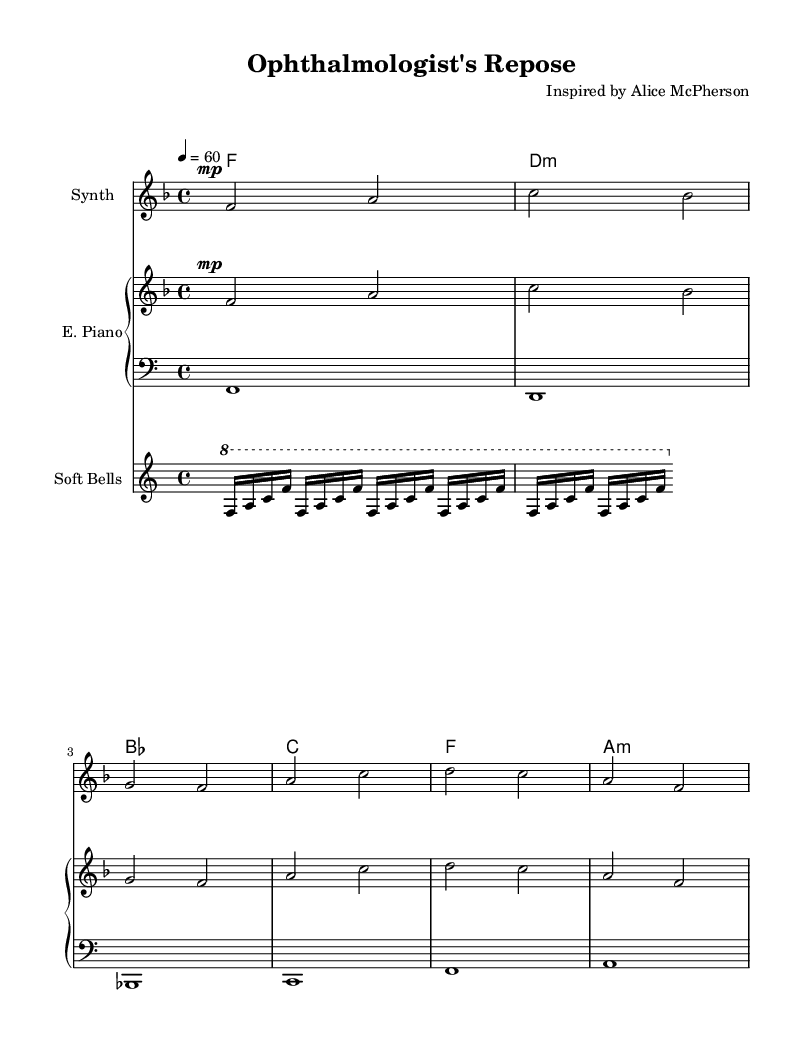What is the key signature of this music? The key signature is determined by the number of sharps or flats present at the beginning of the staff. In this case, there are no sharps or flats visible, indicating that it is F major, which has one flat.
Answer: F major What is the time signature of this piece? The time signature is indicated at the beginning of the music with two numbers, one above the other. Here, the time signature is 4 over 4, which means there are four beats in each measure.
Answer: 4/4 What is the tempo marking of the piece? The tempo is shown at the beginning as text with a number indicating beats per minute. In this score, it is noted as 4 equals 60, signifying a slow pace.
Answer: 60 How many measures are in the melody? To find the number of measures, count how many times the vertical bar lines appear, which indicate the end of each measure. There are six measures in total in the melody.
Answer: 6 What is the first note of the melody? The first note can be found at the beginning of the melody line, which is notated on the staff. The first note here is F, as indicated in the relative pitch notation.
Answer: F What type of instrument is used for the harmony? The instrument designation appears in the music score as "E. Piano" in the staff label for harmony. This suggests that it is performed on an electric piano.
Answer: Electric Piano What instrument plays the bell arpeggio? The score specifies the instrument for the arpeggio as "Soft Bells," which indicates that this part is meant to be played on soft bell sounds.
Answer: Soft Bells 